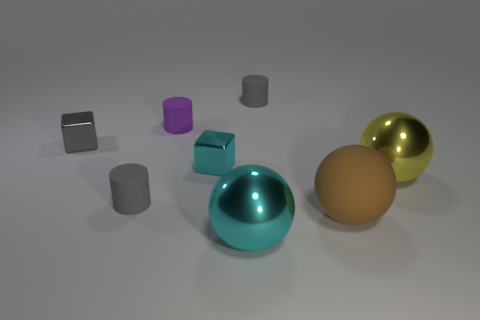Is the size of the rubber ball the same as the gray cylinder behind the tiny purple rubber cylinder? no 